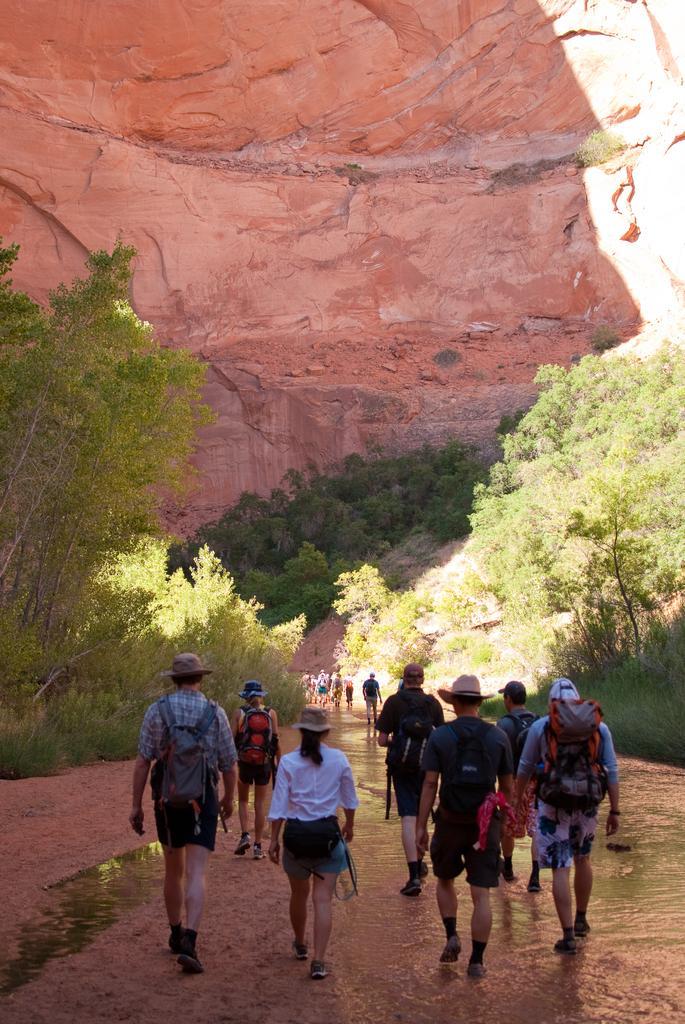Could you give a brief overview of what you see in this image? This picture is clicked outside. In the center we can see the group of persons wearing backpacks and holding some objects and walking on the ground and we can see the rocks, plants and trees. 